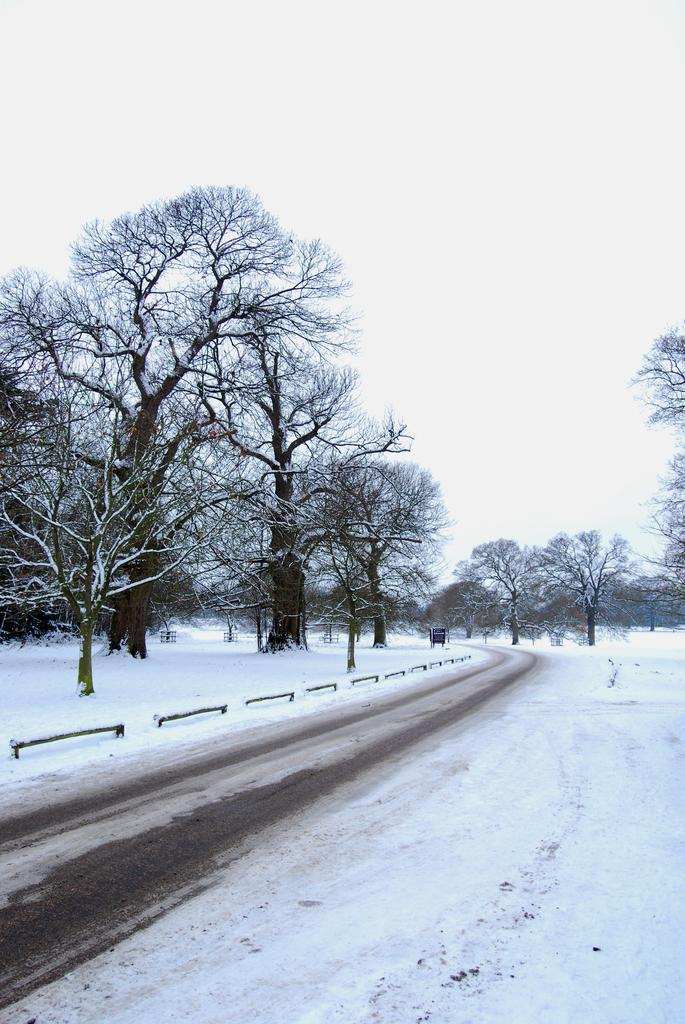What type of vegetation can be seen in the image? There are trees in the image. What is located at the bottom of the image? There is a road at the bottom of the image. What is the weather like in the image? Snow is visible in the image, indicating a snowy environment. What is visible in the background of the image? There is sky visible in the background of the image. Can you tell me how many experts are smiling in the image? There are no experts or smiles present in the image; it features trees, a road, snow, and sky. 